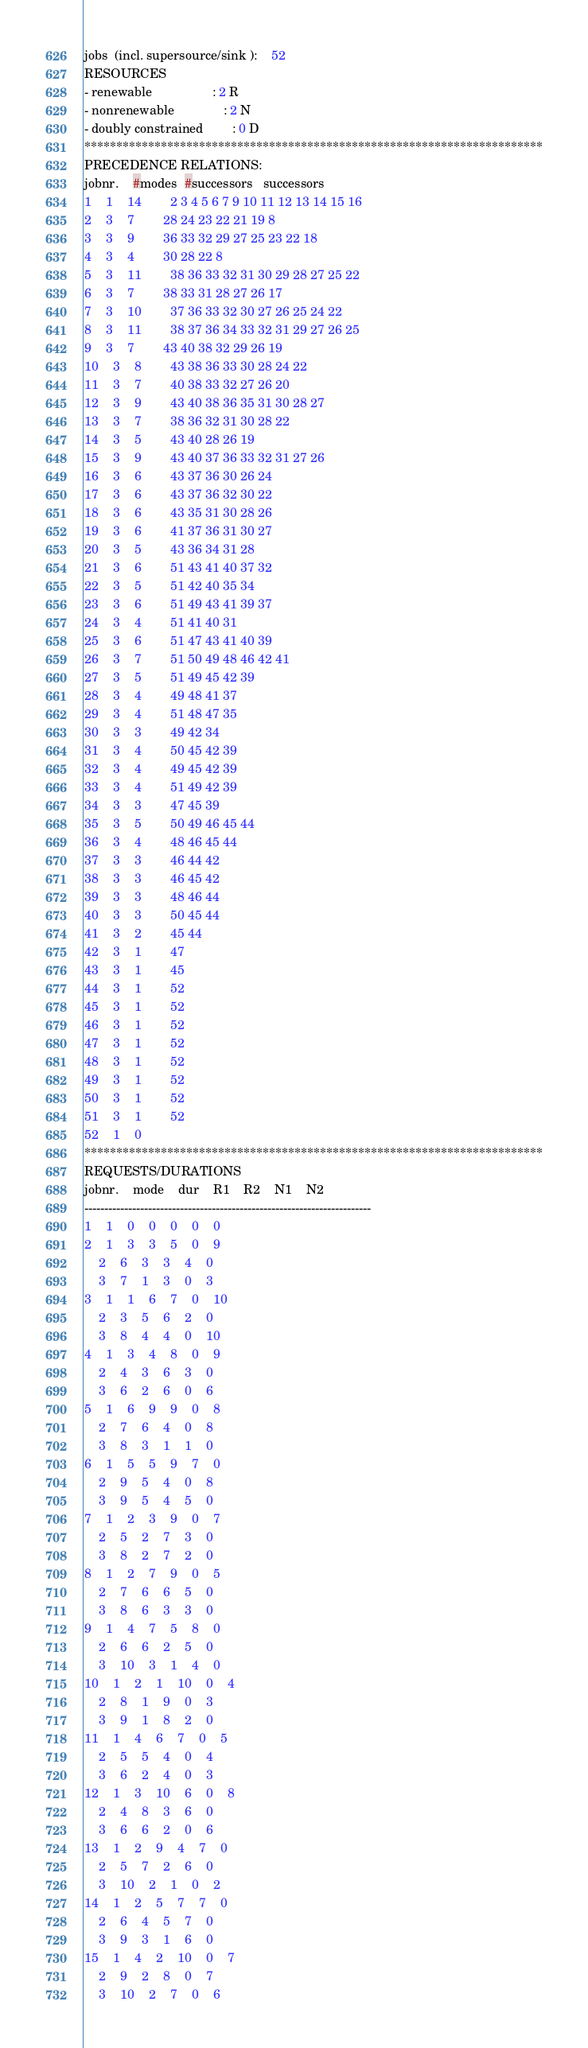Convert code to text. <code><loc_0><loc_0><loc_500><loc_500><_ObjectiveC_>jobs  (incl. supersource/sink ):	52
RESOURCES
- renewable                 : 2 R
- nonrenewable              : 2 N
- doubly constrained        : 0 D
************************************************************************
PRECEDENCE RELATIONS:
jobnr.    #modes  #successors   successors
1	1	14		2 3 4 5 6 7 9 10 11 12 13 14 15 16 
2	3	7		28 24 23 22 21 19 8 
3	3	9		36 33 32 29 27 25 23 22 18 
4	3	4		30 28 22 8 
5	3	11		38 36 33 32 31 30 29 28 27 25 22 
6	3	7		38 33 31 28 27 26 17 
7	3	10		37 36 33 32 30 27 26 25 24 22 
8	3	11		38 37 36 34 33 32 31 29 27 26 25 
9	3	7		43 40 38 32 29 26 19 
10	3	8		43 38 36 33 30 28 24 22 
11	3	7		40 38 33 32 27 26 20 
12	3	9		43 40 38 36 35 31 30 28 27 
13	3	7		38 36 32 31 30 28 22 
14	3	5		43 40 28 26 19 
15	3	9		43 40 37 36 33 32 31 27 26 
16	3	6		43 37 36 30 26 24 
17	3	6		43 37 36 32 30 22 
18	3	6		43 35 31 30 28 26 
19	3	6		41 37 36 31 30 27 
20	3	5		43 36 34 31 28 
21	3	6		51 43 41 40 37 32 
22	3	5		51 42 40 35 34 
23	3	6		51 49 43 41 39 37 
24	3	4		51 41 40 31 
25	3	6		51 47 43 41 40 39 
26	3	7		51 50 49 48 46 42 41 
27	3	5		51 49 45 42 39 
28	3	4		49 48 41 37 
29	3	4		51 48 47 35 
30	3	3		49 42 34 
31	3	4		50 45 42 39 
32	3	4		49 45 42 39 
33	3	4		51 49 42 39 
34	3	3		47 45 39 
35	3	5		50 49 46 45 44 
36	3	4		48 46 45 44 
37	3	3		46 44 42 
38	3	3		46 45 42 
39	3	3		48 46 44 
40	3	3		50 45 44 
41	3	2		45 44 
42	3	1		47 
43	3	1		45 
44	3	1		52 
45	3	1		52 
46	3	1		52 
47	3	1		52 
48	3	1		52 
49	3	1		52 
50	3	1		52 
51	3	1		52 
52	1	0		
************************************************************************
REQUESTS/DURATIONS
jobnr.	mode	dur	R1	R2	N1	N2	
------------------------------------------------------------------------
1	1	0	0	0	0	0	
2	1	3	3	5	0	9	
	2	6	3	3	4	0	
	3	7	1	3	0	3	
3	1	1	6	7	0	10	
	2	3	5	6	2	0	
	3	8	4	4	0	10	
4	1	3	4	8	0	9	
	2	4	3	6	3	0	
	3	6	2	6	0	6	
5	1	6	9	9	0	8	
	2	7	6	4	0	8	
	3	8	3	1	1	0	
6	1	5	5	9	7	0	
	2	9	5	4	0	8	
	3	9	5	4	5	0	
7	1	2	3	9	0	7	
	2	5	2	7	3	0	
	3	8	2	7	2	0	
8	1	2	7	9	0	5	
	2	7	6	6	5	0	
	3	8	6	3	3	0	
9	1	4	7	5	8	0	
	2	6	6	2	5	0	
	3	10	3	1	4	0	
10	1	2	1	10	0	4	
	2	8	1	9	0	3	
	3	9	1	8	2	0	
11	1	4	6	7	0	5	
	2	5	5	4	0	4	
	3	6	2	4	0	3	
12	1	3	10	6	0	8	
	2	4	8	3	6	0	
	3	6	6	2	0	6	
13	1	2	9	4	7	0	
	2	5	7	2	6	0	
	3	10	2	1	0	2	
14	1	2	5	7	7	0	
	2	6	4	5	7	0	
	3	9	3	1	6	0	
15	1	4	2	10	0	7	
	2	9	2	8	0	7	
	3	10	2	7	0	6	</code> 